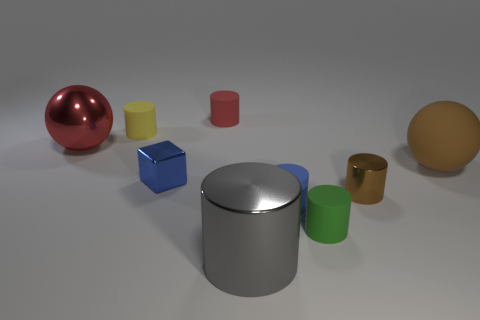Subtract all big shiny cylinders. How many cylinders are left? 5 Subtract all cubes. How many objects are left? 8 Add 1 green rubber things. How many objects exist? 10 Subtract all brown cylinders. How many cylinders are left? 5 Subtract all green blocks. Subtract all brown cylinders. How many blocks are left? 1 Add 2 small blue objects. How many small blue objects are left? 4 Add 3 large balls. How many large balls exist? 5 Subtract 1 red cylinders. How many objects are left? 8 Subtract 1 spheres. How many spheres are left? 1 Subtract all tiny gray things. Subtract all small blue rubber things. How many objects are left? 8 